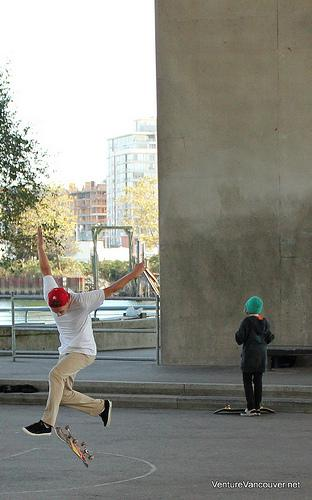Question: who is wearing khaki pants?
Choices:
A. The woman on the right.
B. The man on the right.
C. The woman on the left.
D. The boy on the left.
Answer with the letter. Answer: D Question: when is this picture taken?
Choices:
A. At night.
B. During the day.
C. Sunrise.
D. Afternoon.
Answer with the letter. Answer: B Question: who is bearing a red colored hat?
Choices:
A. The boy on the left.
B. The girl on the right.
C. The boy on the right.
D. The woman on the left.
Answer with the letter. Answer: A Question: what color are the walls?
Choices:
A. Beige.
B. Gray.
C. Green.
D. Blue.
Answer with the letter. Answer: B Question: how many people are there?
Choices:
A. Two.
B. One.
C. Four.
D. Zero.
Answer with the letter. Answer: A 